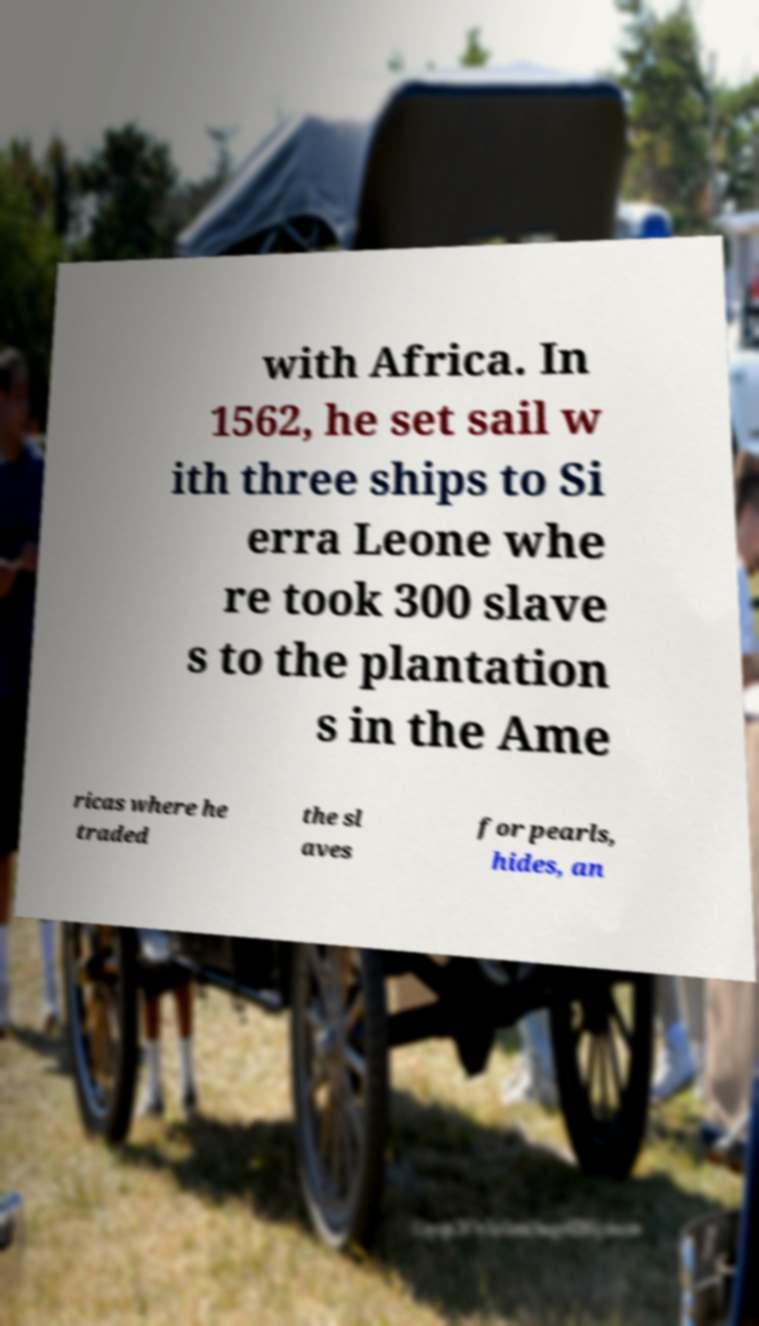There's text embedded in this image that I need extracted. Can you transcribe it verbatim? with Africa. In 1562, he set sail w ith three ships to Si erra Leone whe re took 300 slave s to the plantation s in the Ame ricas where he traded the sl aves for pearls, hides, an 